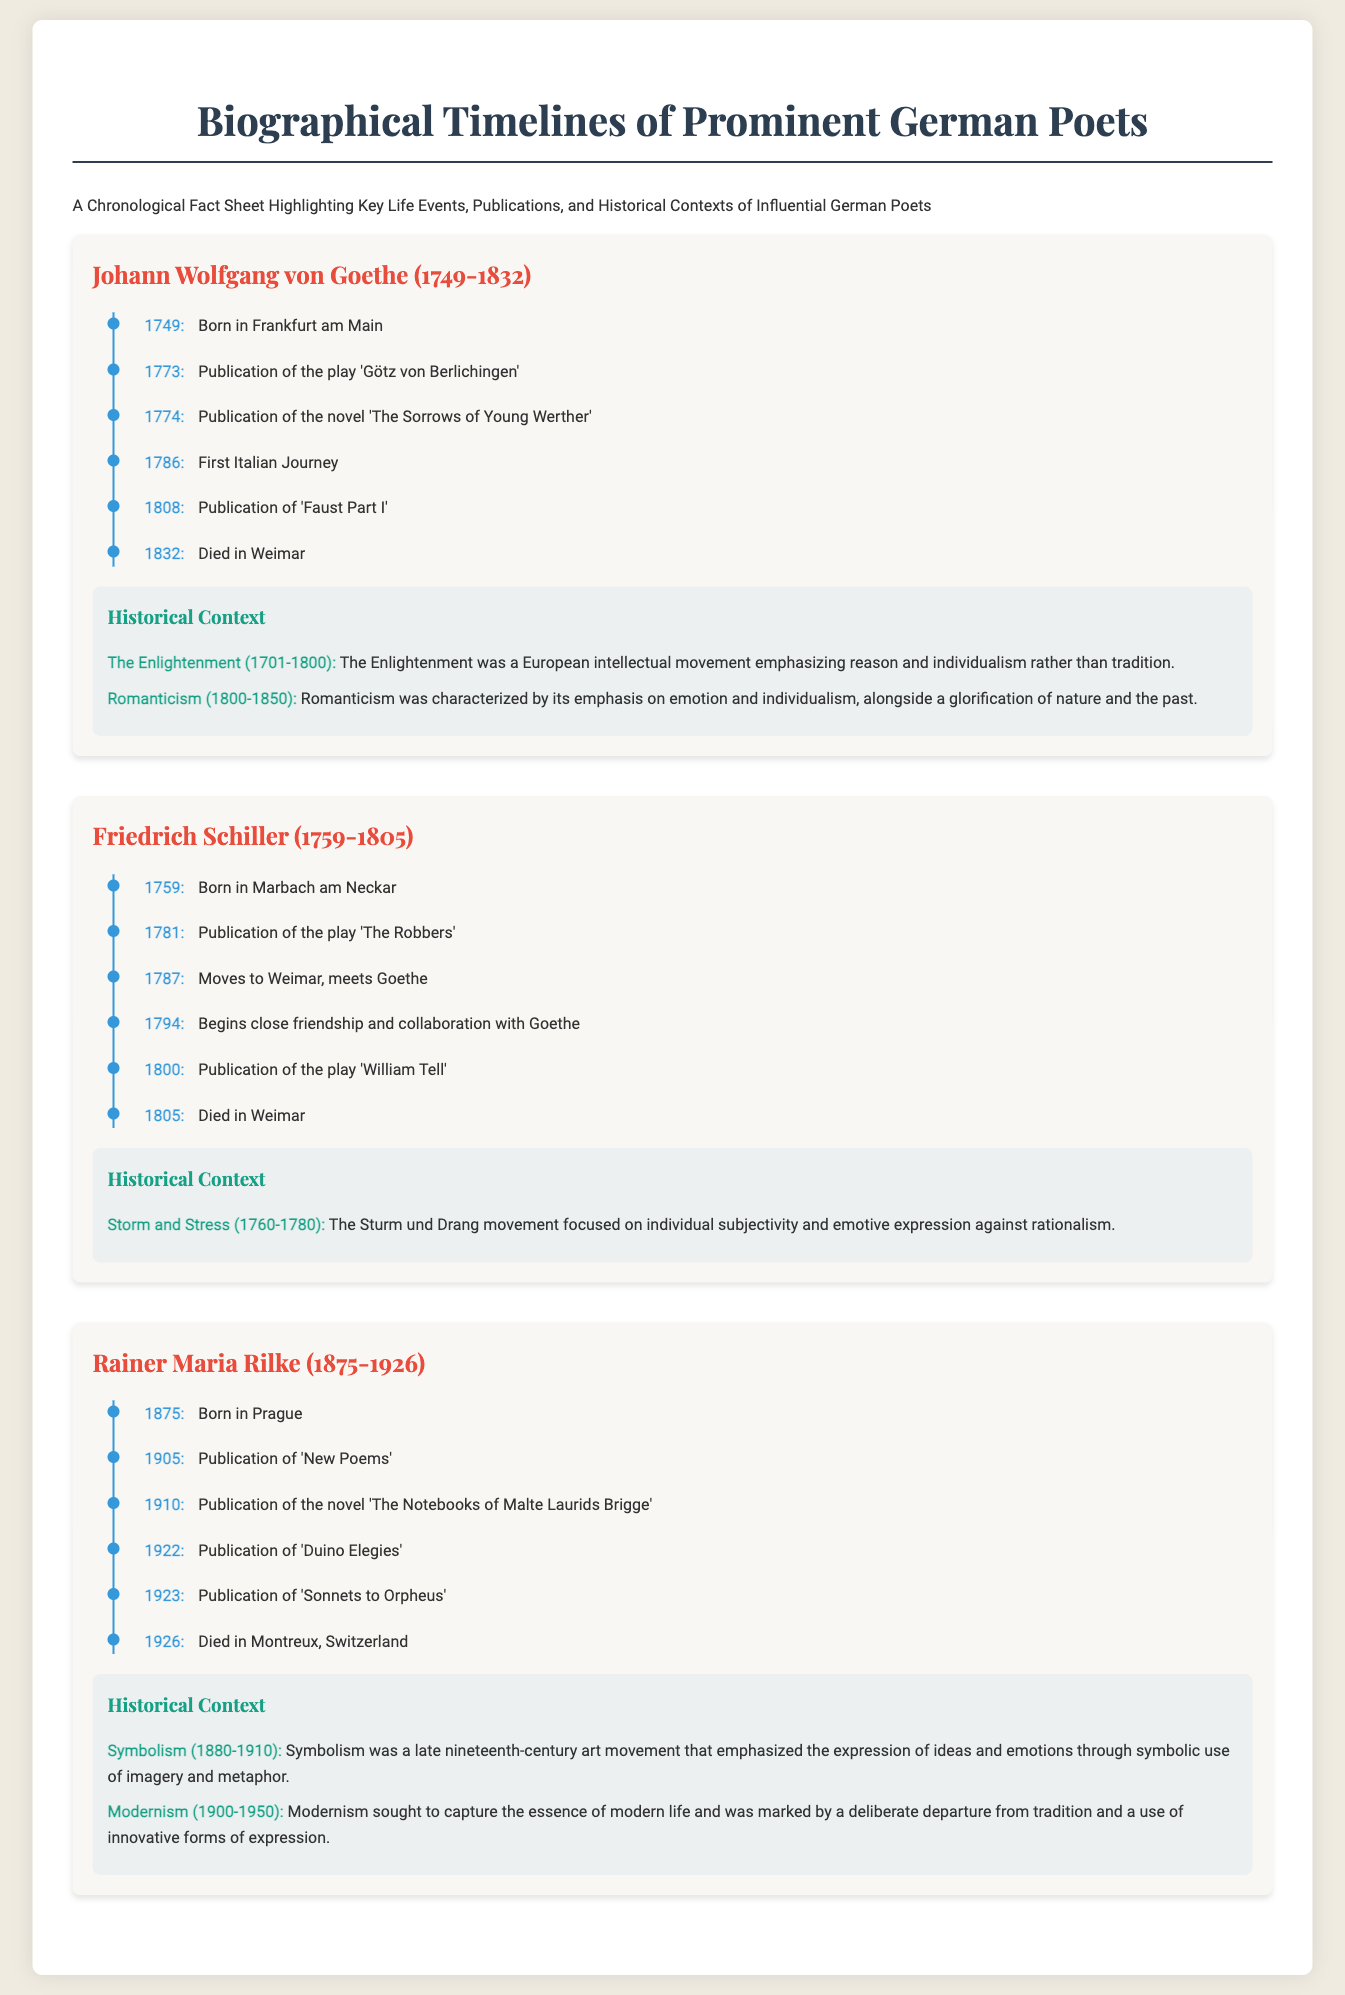What year was Johann Wolfgang von Goethe born? The document states that Johann Wolfgang von Goethe was born in 1749.
Answer: 1749 Which play did Friedrich Schiller publish in 1781? According to the timeline, Friedrich Schiller published 'The Robbers' in 1781.
Answer: The Robbers What significant event in Goethe's life occurred in 1786? The document mentions that the first Italian Journey took place for Goethe in 1786.
Answer: First Italian Journey How many key events are listed for Rainer Maria Rilke? The timeline contains six events regarding Rainer Maria Rilke's life.
Answer: Six What literary movement is associated with Rainer Maria Rilke? The document associates Rainer Maria Rilke with the Symbolism movement (1880-1910).
Answer: Symbolism Which poet died in Weimar? The fact sheet states that both Friedrich Schiller and Johann Wolfgang von Goethe died in Weimar.
Answer: Johann Wolfgang von Goethe and Friedrich Schiller What year did Friedrich Schiller move to Weimar? The document indicates that Friedrich Schiller moved to Weimar in 1787.
Answer: 1787 What style is the historical context section presented in? The historical context section is presented in a box format with a different background color for emphasis.
Answer: Box format with a different background color 